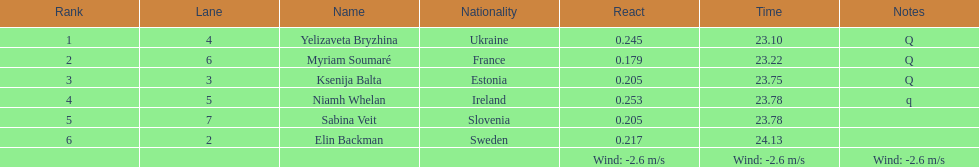How long did it take elin backman to finish the race? 24.13. 